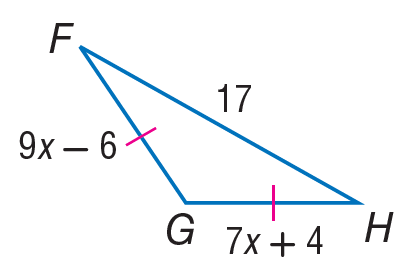Answer the mathemtical geometry problem and directly provide the correct option letter.
Question: Find the length of F G.
Choices: A: 17 B: 35 C: 39 D: 45 C 